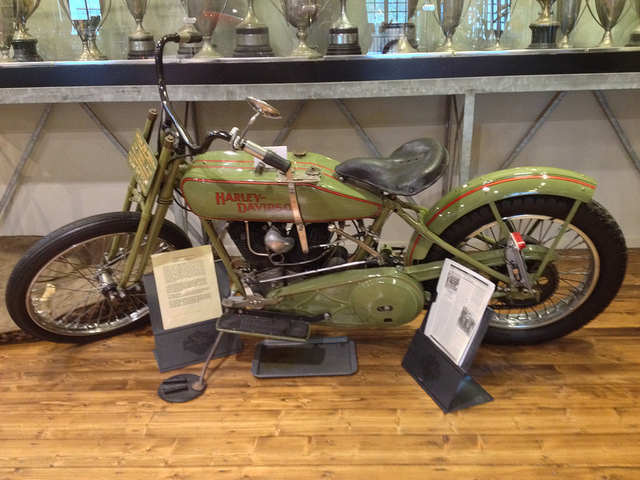Extract all visible text content from this image. HARLEY DAVIDSO 